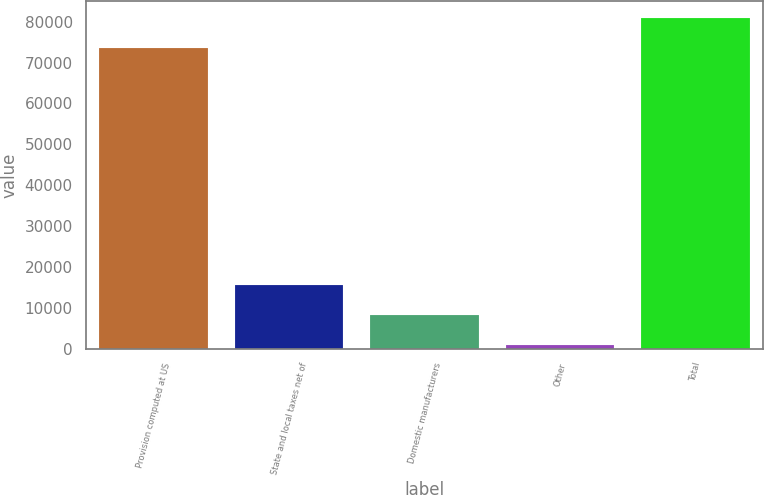<chart> <loc_0><loc_0><loc_500><loc_500><bar_chart><fcel>Provision computed at US<fcel>State and local taxes net of<fcel>Domestic manufacturers<fcel>Other<fcel>Total<nl><fcel>73550<fcel>15558.8<fcel>8186.9<fcel>815<fcel>80921.9<nl></chart> 